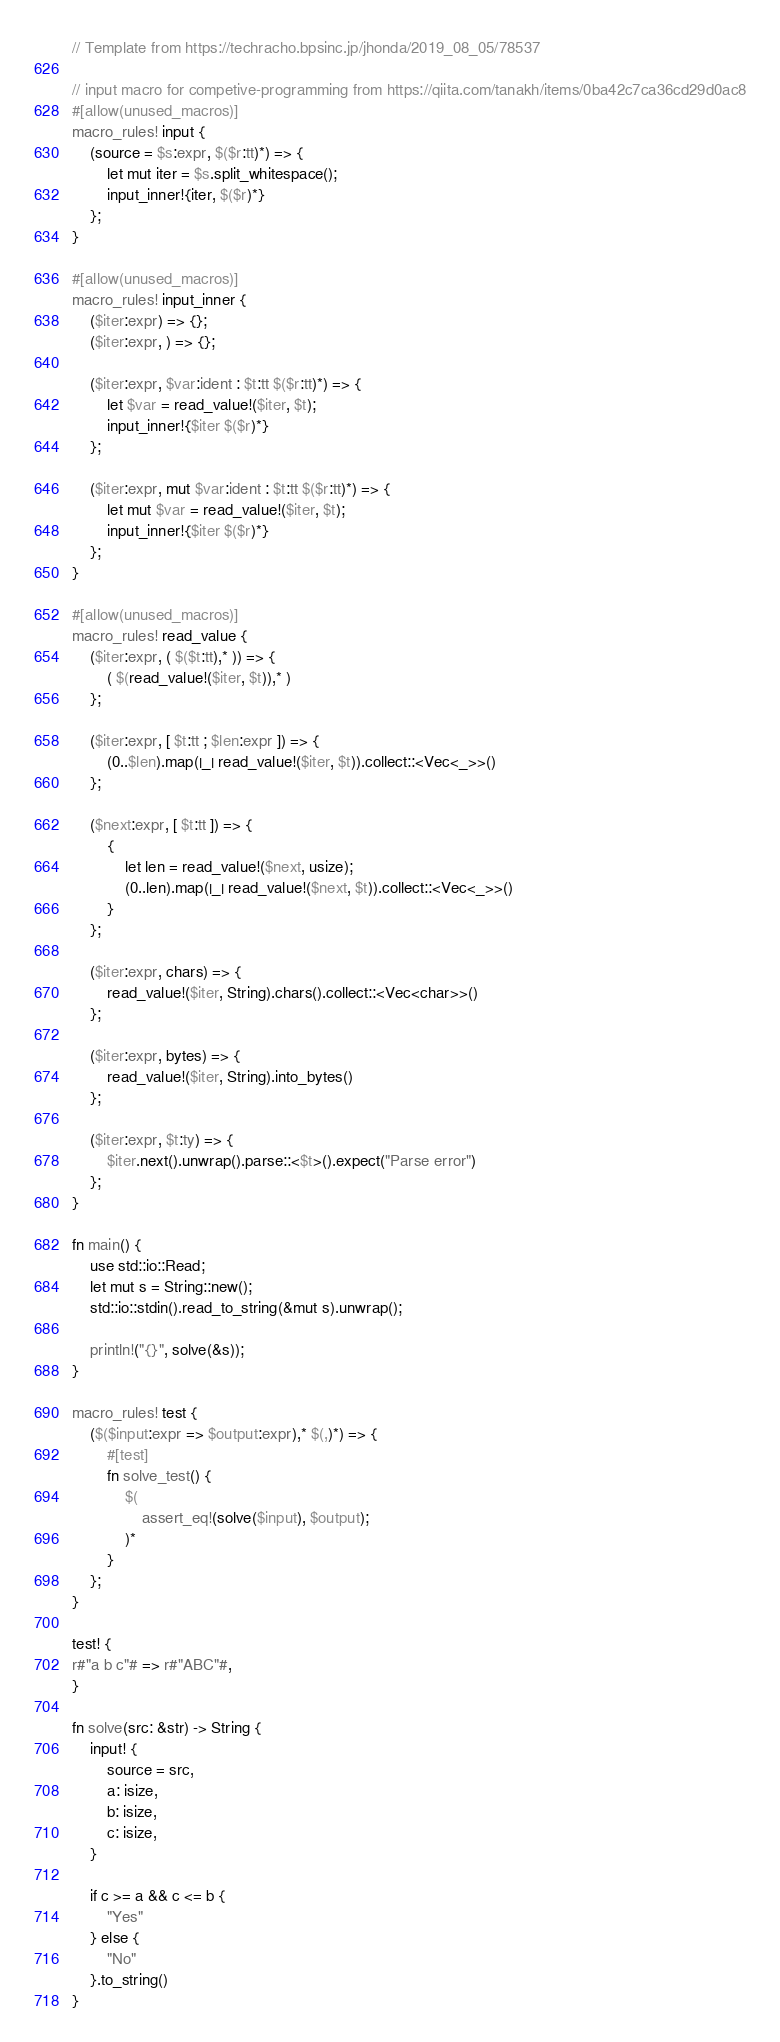Convert code to text. <code><loc_0><loc_0><loc_500><loc_500><_Rust_>// Template from https://techracho.bpsinc.jp/jhonda/2019_08_05/78537

// input macro for competive-programming from https://qiita.com/tanakh/items/0ba42c7ca36cd29d0ac8
#[allow(unused_macros)]
macro_rules! input {
    (source = $s:expr, $($r:tt)*) => {
        let mut iter = $s.split_whitespace();
        input_inner!{iter, $($r)*}
    };
}

#[allow(unused_macros)]
macro_rules! input_inner {
    ($iter:expr) => {};
    ($iter:expr, ) => {};

    ($iter:expr, $var:ident : $t:tt $($r:tt)*) => {
        let $var = read_value!($iter, $t);
        input_inner!{$iter $($r)*}
    };

    ($iter:expr, mut $var:ident : $t:tt $($r:tt)*) => {
        let mut $var = read_value!($iter, $t);
        input_inner!{$iter $($r)*}
    };
}

#[allow(unused_macros)]
macro_rules! read_value {
    ($iter:expr, ( $($t:tt),* )) => {
        ( $(read_value!($iter, $t)),* )
    };

    ($iter:expr, [ $t:tt ; $len:expr ]) => {
        (0..$len).map(|_| read_value!($iter, $t)).collect::<Vec<_>>()
    };

    ($next:expr, [ $t:tt ]) => {
        {
            let len = read_value!($next, usize);
            (0..len).map(|_| read_value!($next, $t)).collect::<Vec<_>>()
        }
    };

    ($iter:expr, chars) => {
        read_value!($iter, String).chars().collect::<Vec<char>>()
    };

    ($iter:expr, bytes) => {
        read_value!($iter, String).into_bytes()
    };

    ($iter:expr, $t:ty) => {
        $iter.next().unwrap().parse::<$t>().expect("Parse error")
    };
}

fn main() {
    use std::io::Read;
    let mut s = String::new();
    std::io::stdin().read_to_string(&mut s).unwrap();

    println!("{}", solve(&s));
}

macro_rules! test {
    ($($input:expr => $output:expr),* $(,)*) => {
        #[test]
        fn solve_test() {
            $(
                assert_eq!(solve($input), $output);
            )*
        }
    };
}

test! {
r#"a b c"# => r#"ABC"#,
}

fn solve(src: &str) -> String {
    input! {
        source = src,
        a: isize,
        b: isize,
        c: isize,
    }

    if c >= a && c <= b {
        "Yes"
    } else {
        "No"
    }.to_string()
}</code> 